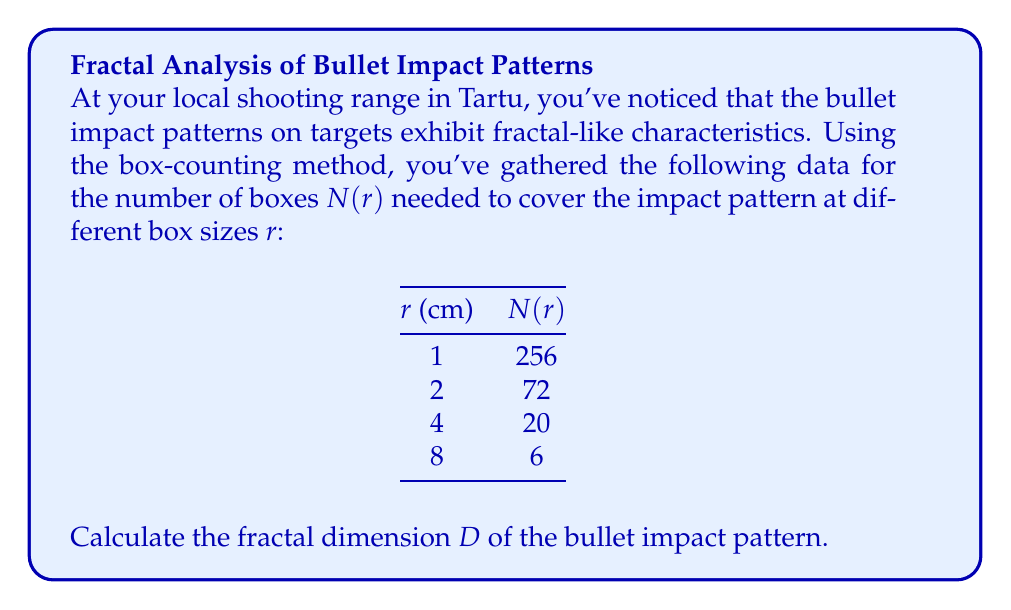What is the answer to this math problem? To determine the fractal dimension using the box-counting method, we follow these steps:

1. Recall the box-counting dimension formula:
   $$D = -\lim_{r \to 0} \frac{\log N(r)}{\log r}$$

2. In practice, we can estimate D by plotting $\log N(r)$ against $\log r$ and finding the slope of the best-fit line.

3. Calculate $\log r$ and $\log N(r)$ for each data point:

   r (cm) | N(r) | log r | log N(r)
   1      | 256  | 0     | 5.5452
   2      | 72   | 0.6931| 4.2767
   4      | 20   | 1.3863| 2.9957
   8      | 6    | 2.0794| 1.7918

4. Plot these points and find the slope of the best-fit line. We can use the least squares method to find the slope:

   $$m = -\frac{n\sum(x_i y_i) - \sum x_i \sum y_i}{n\sum x_i^2 - (\sum x_i)^2}$$

   Where $x_i = \log r_i$ and $y_i = \log N(r_i)$

5. Calculate the sums:
   $\sum x_i = 4.1588$
   $\sum y_i = 14.6094$
   $\sum(x_i y_i) = 11.7651$
   $\sum x_i^2 = 6.9284$
   $n = 4$

6. Plug these values into the slope formula:

   $$m = -\frac{4(11.7651) - (4.1588)(14.6094)}{4(6.9284) - (4.1588)^2} = -1.7826$$

7. The negative of this slope is our estimate for the fractal dimension D:

   $$D \approx 1.7826$$

This fractional dimension between 1 and 2 suggests that the bullet impact pattern has a fractal nature, being more complex than a simple line (dimension 1) but not filling the plane completely (dimension 2).
Answer: $D \approx 1.7826$ 